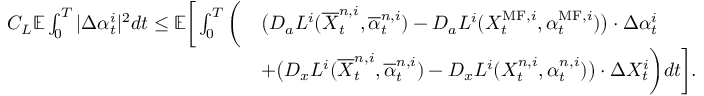<formula> <loc_0><loc_0><loc_500><loc_500>\begin{array} { r l } { C _ { L } { \mathbb { E } } \int _ { 0 } ^ { T } | \Delta \alpha _ { t } ^ { i } | ^ { 2 } d t \leq { \mathbb { E } } \left [ \int _ { 0 } ^ { T } \left ( } & { \left ( D _ { a } L ^ { i } ( \overline { X } _ { t } ^ { n , i } , \overline { \alpha } _ { t } ^ { n , i } ) - D _ { a } L ^ { i } ( X _ { t } ^ { M F , i } , \alpha _ { t } ^ { M F , i } ) \right ) \cdot \Delta \alpha _ { t } ^ { i } } \\ & { + \left ( D _ { x } L ^ { i } ( \overline { X } _ { t } ^ { n , i } , \overline { \alpha } _ { t } ^ { n , i } ) - D _ { x } L ^ { i } ( X _ { t } ^ { n , i } , \alpha _ { t } ^ { n , i } ) \right ) \cdot \Delta X _ { t } ^ { i } \right ) d t \right ] . } \end{array}</formula> 